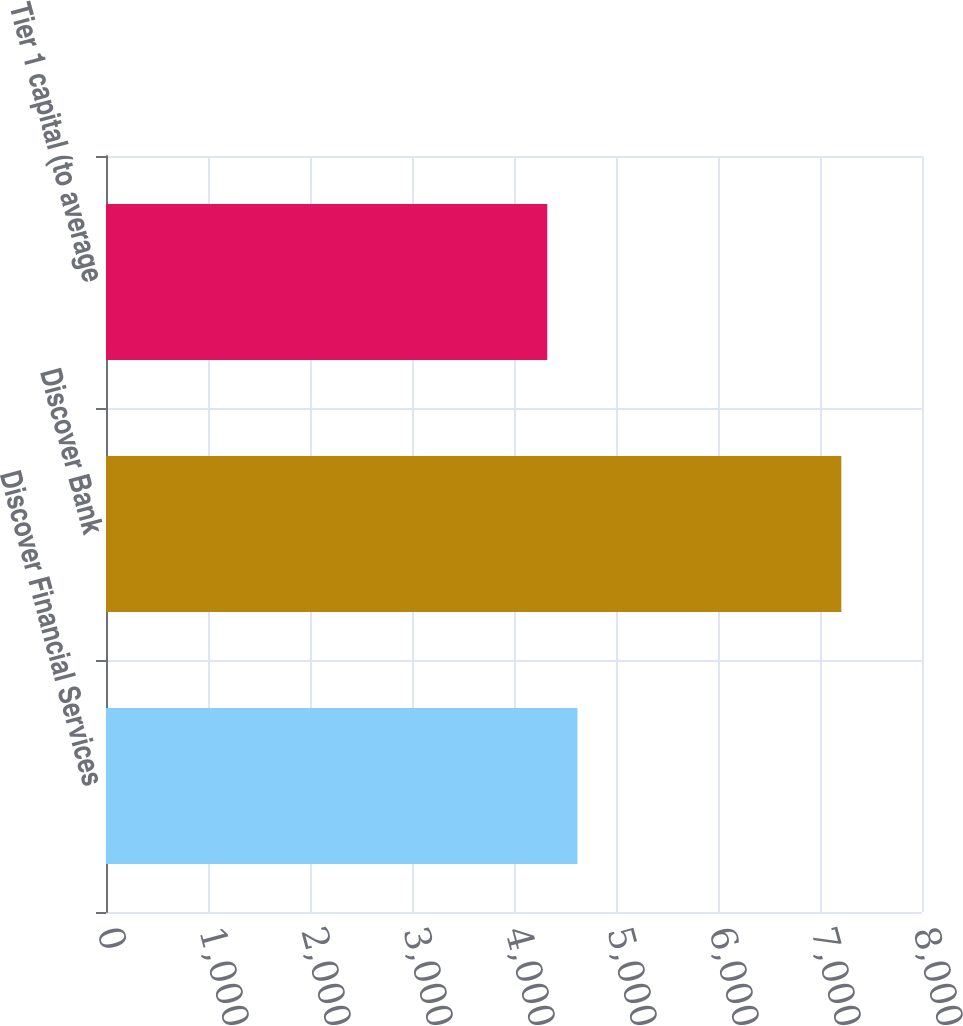<chart> <loc_0><loc_0><loc_500><loc_500><bar_chart><fcel>Discover Financial Services<fcel>Discover Bank<fcel>Tier 1 capital (to average<nl><fcel>4622.3<fcel>7209<fcel>4326<nl></chart> 